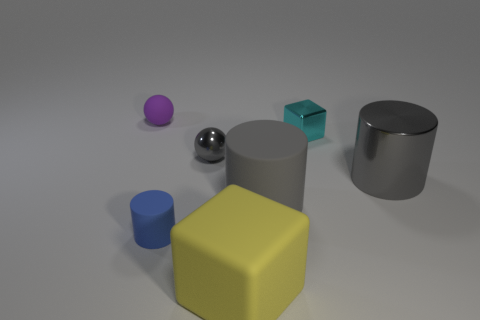What material is the other big gray object that is the same shape as the big shiny object?
Ensure brevity in your answer.  Rubber. The tiny object in front of the big gray cylinder that is right of the tiny block is made of what material?
Your answer should be compact. Rubber. Does the large yellow object have the same shape as the small blue thing that is in front of the tiny purple matte object?
Keep it short and to the point. No. What number of metallic things are either yellow objects or small purple balls?
Your answer should be very brief. 0. There is a matte object that is in front of the small rubber thing that is on the right side of the rubber object behind the gray sphere; what is its color?
Offer a terse response. Yellow. What number of other things are made of the same material as the tiny blue cylinder?
Provide a succinct answer. 3. Does the small metal object that is on the right side of the tiny gray shiny ball have the same shape as the yellow object?
Keep it short and to the point. Yes. How many big things are either cylinders or balls?
Ensure brevity in your answer.  2. Is the number of small gray shiny things behind the small shiny sphere the same as the number of cylinders that are on the left side of the blue rubber thing?
Give a very brief answer. Yes. What number of other things are the same color as the metal cylinder?
Your answer should be compact. 2. 